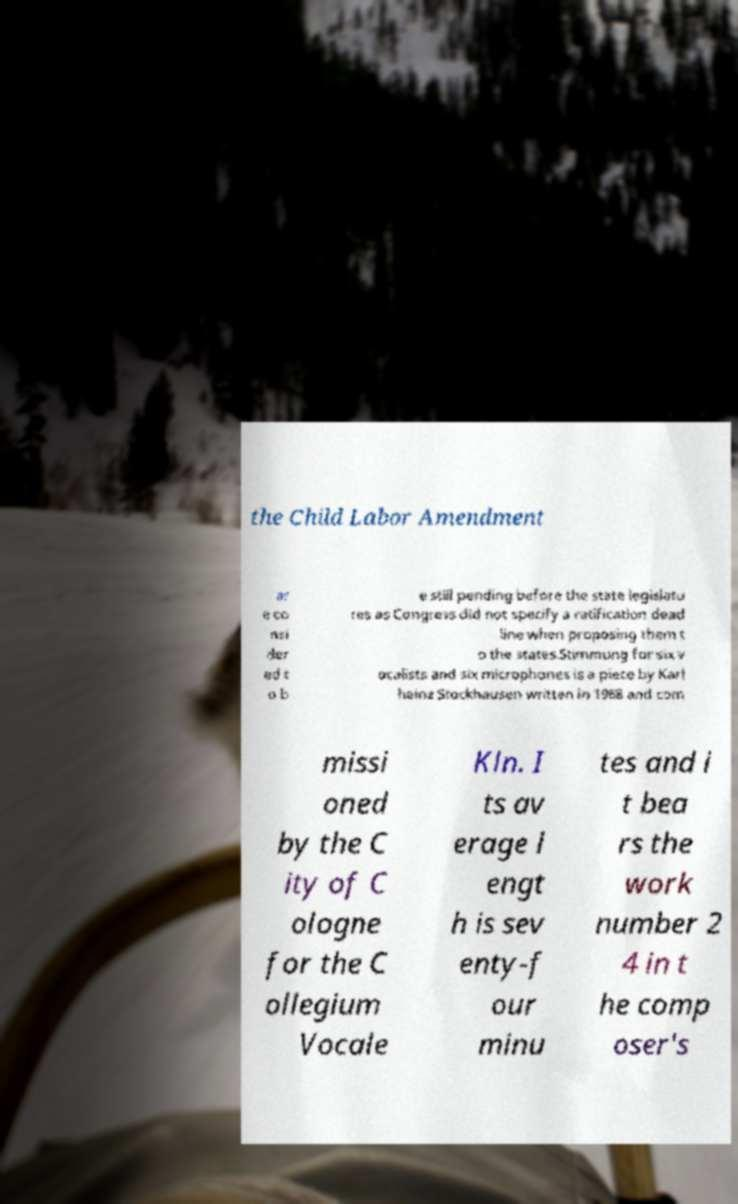For documentation purposes, I need the text within this image transcribed. Could you provide that? the Child Labor Amendment ar e co nsi der ed t o b e still pending before the state legislatu res as Congress did not specify a ratification dead line when proposing them t o the states.Stimmung for six v ocalists and six microphones is a piece by Karl heinz Stockhausen written in 1968 and com missi oned by the C ity of C ologne for the C ollegium Vocale Kln. I ts av erage l engt h is sev enty-f our minu tes and i t bea rs the work number 2 4 in t he comp oser's 